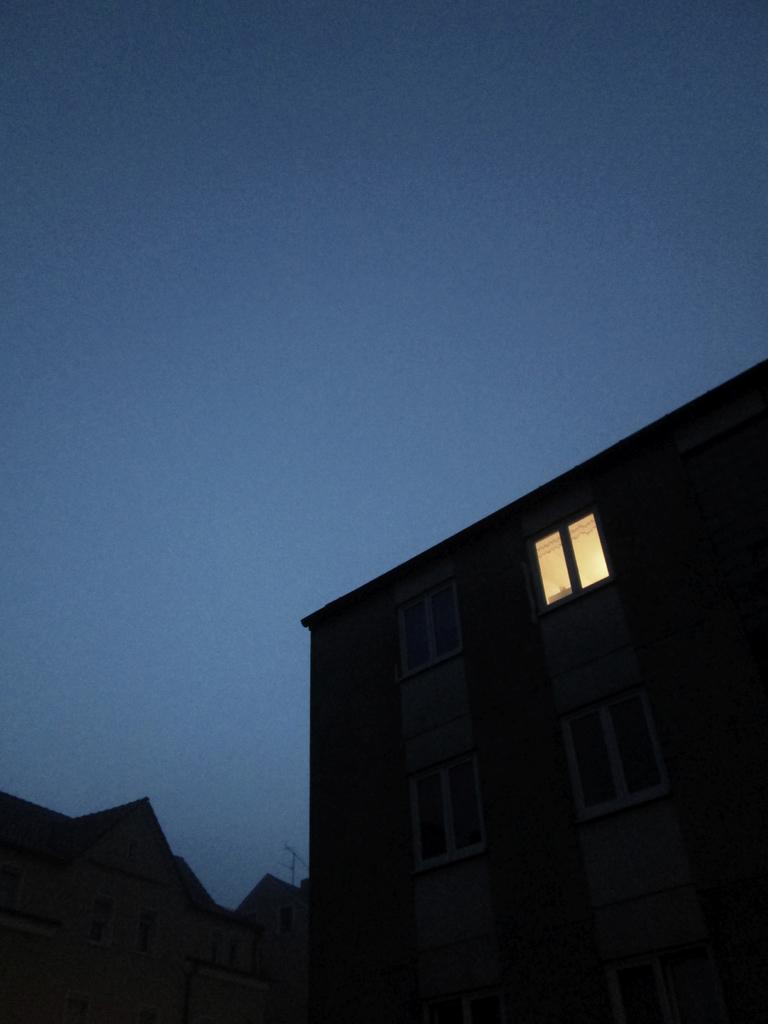What type of structures are present in the image? There are buildings in the image. What is visible at the top of the image? The sky is visible at the top of the image. What color is the sky in the image? The sky is blue in the image. How is the glue used to construct the houses in the image? There are no houses present in the image, and glue is not mentioned as a construction material. 